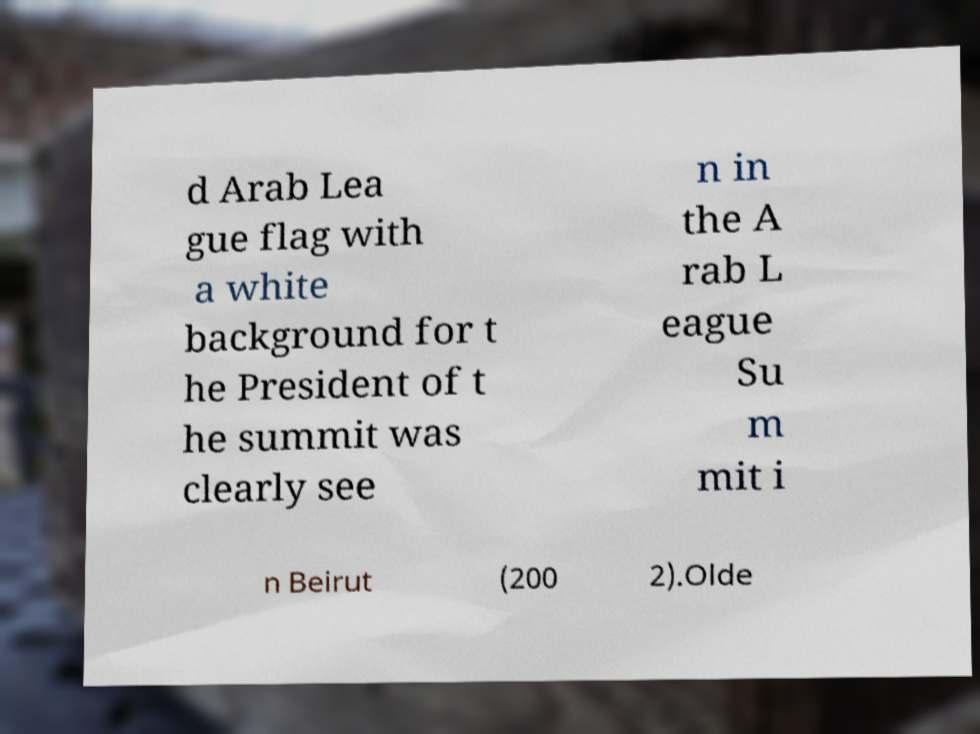Please identify and transcribe the text found in this image. d Arab Lea gue flag with a white background for t he President of t he summit was clearly see n in the A rab L eague Su m mit i n Beirut (200 2).Olde 